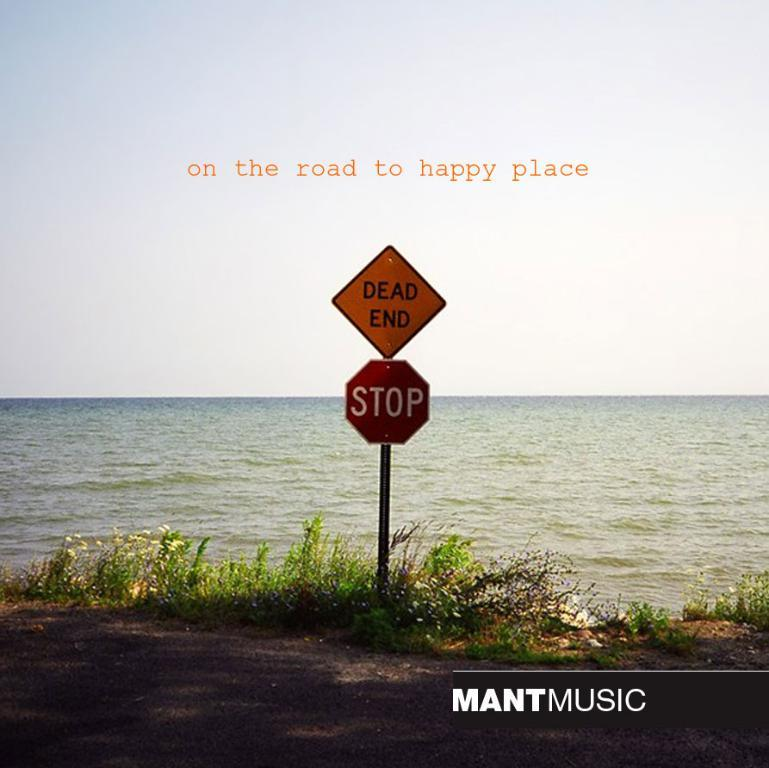<image>
Write a terse but informative summary of the picture. A stop sign and dead end sign at the edge of the ocean. 